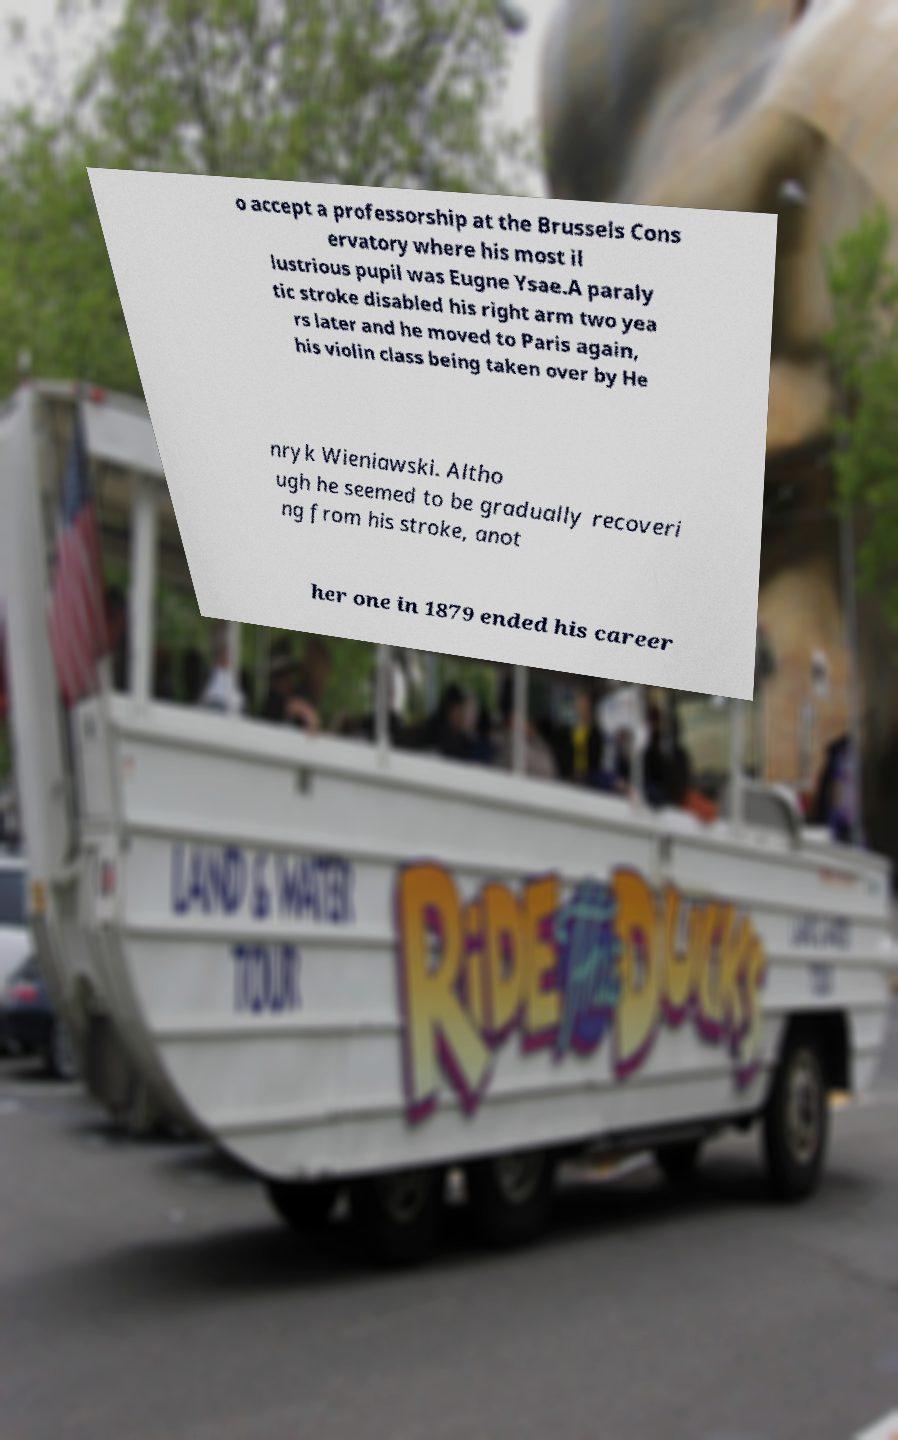I need the written content from this picture converted into text. Can you do that? o accept a professorship at the Brussels Cons ervatory where his most il lustrious pupil was Eugne Ysae.A paraly tic stroke disabled his right arm two yea rs later and he moved to Paris again, his violin class being taken over by He nryk Wieniawski. Altho ugh he seemed to be gradually recoveri ng from his stroke, anot her one in 1879 ended his career 